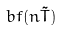Convert formula to latex. <formula><loc_0><loc_0><loc_500><loc_500>b f ( n \tilde { T } )</formula> 